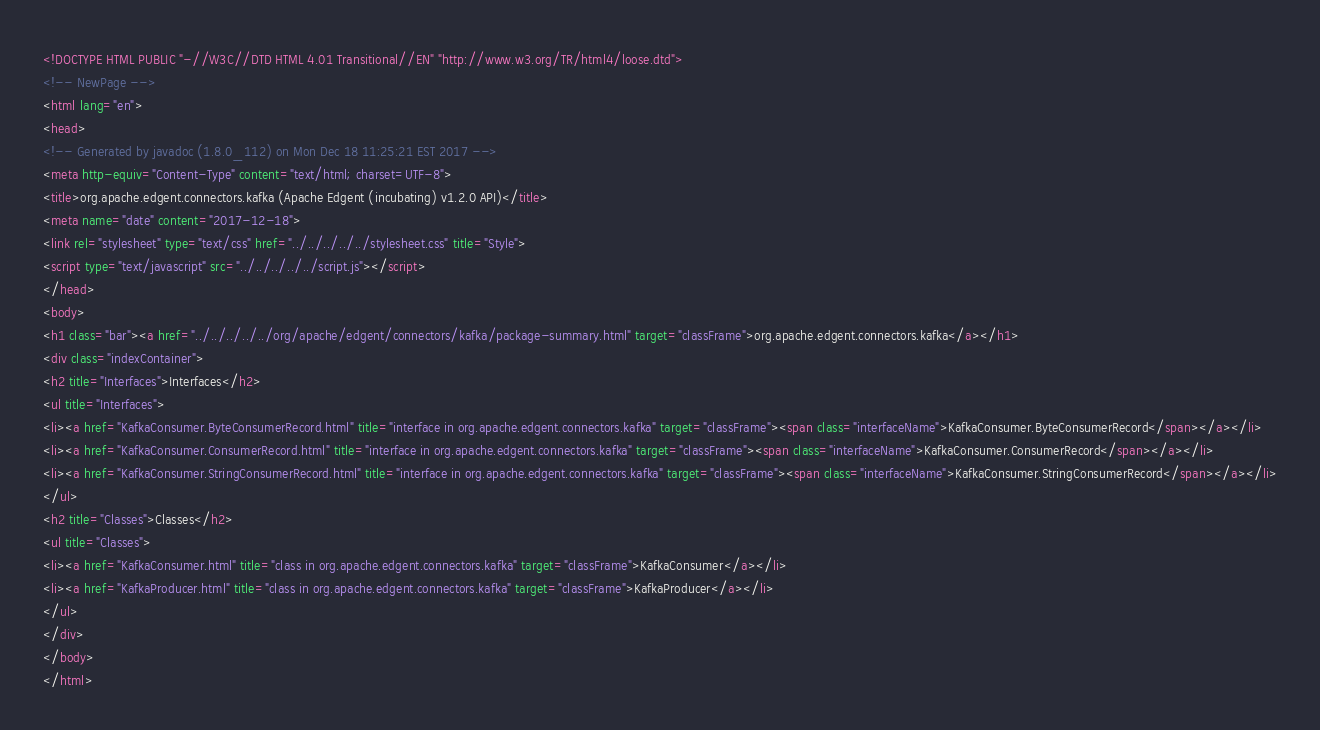Convert code to text. <code><loc_0><loc_0><loc_500><loc_500><_HTML_><!DOCTYPE HTML PUBLIC "-//W3C//DTD HTML 4.01 Transitional//EN" "http://www.w3.org/TR/html4/loose.dtd">
<!-- NewPage -->
<html lang="en">
<head>
<!-- Generated by javadoc (1.8.0_112) on Mon Dec 18 11:25:21 EST 2017 -->
<meta http-equiv="Content-Type" content="text/html; charset=UTF-8">
<title>org.apache.edgent.connectors.kafka (Apache Edgent (incubating) v1.2.0 API)</title>
<meta name="date" content="2017-12-18">
<link rel="stylesheet" type="text/css" href="../../../../../stylesheet.css" title="Style">
<script type="text/javascript" src="../../../../../script.js"></script>
</head>
<body>
<h1 class="bar"><a href="../../../../../org/apache/edgent/connectors/kafka/package-summary.html" target="classFrame">org.apache.edgent.connectors.kafka</a></h1>
<div class="indexContainer">
<h2 title="Interfaces">Interfaces</h2>
<ul title="Interfaces">
<li><a href="KafkaConsumer.ByteConsumerRecord.html" title="interface in org.apache.edgent.connectors.kafka" target="classFrame"><span class="interfaceName">KafkaConsumer.ByteConsumerRecord</span></a></li>
<li><a href="KafkaConsumer.ConsumerRecord.html" title="interface in org.apache.edgent.connectors.kafka" target="classFrame"><span class="interfaceName">KafkaConsumer.ConsumerRecord</span></a></li>
<li><a href="KafkaConsumer.StringConsumerRecord.html" title="interface in org.apache.edgent.connectors.kafka" target="classFrame"><span class="interfaceName">KafkaConsumer.StringConsumerRecord</span></a></li>
</ul>
<h2 title="Classes">Classes</h2>
<ul title="Classes">
<li><a href="KafkaConsumer.html" title="class in org.apache.edgent.connectors.kafka" target="classFrame">KafkaConsumer</a></li>
<li><a href="KafkaProducer.html" title="class in org.apache.edgent.connectors.kafka" target="classFrame">KafkaProducer</a></li>
</ul>
</div>
</body>
</html>
</code> 